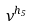Convert formula to latex. <formula><loc_0><loc_0><loc_500><loc_500>\nu ^ { h _ { 5 } }</formula> 